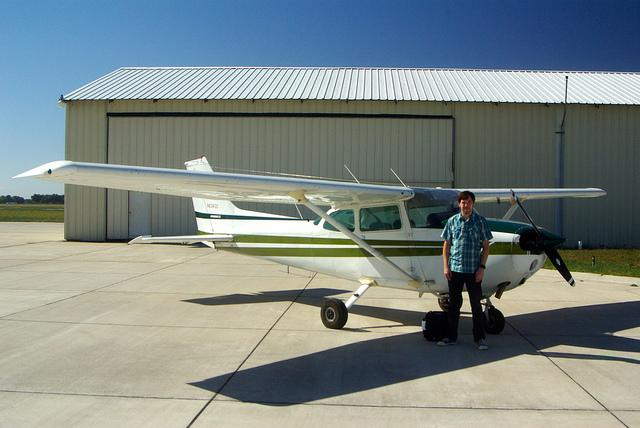Who is this person most likely to be? Please explain your reasoning. pilot. The person is standing near a plane. 